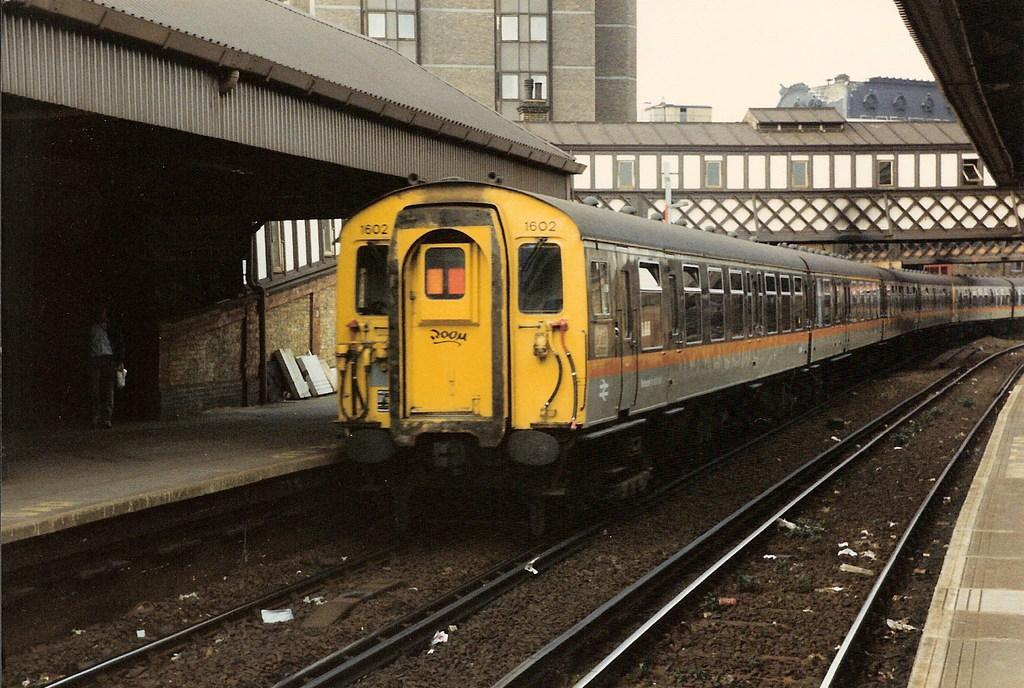What is the main subject of the image? The main subject of the image is a train on the track. What can be seen in the foreground of the image? There are tracks visible in the image, as well as a platform. Is there any human presence in the image? Yes, there is a person standing in the image. What other structures can be seen in the image? There is a shed in the image. What is visible in the background of the image? There are buildings and the sky visible in the background of the image. What type of drug is being sold at the train station in the image? There is no indication of any drug sales or activity in the image. 